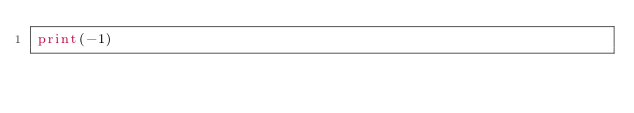Convert code to text. <code><loc_0><loc_0><loc_500><loc_500><_Python_>print(-1)</code> 